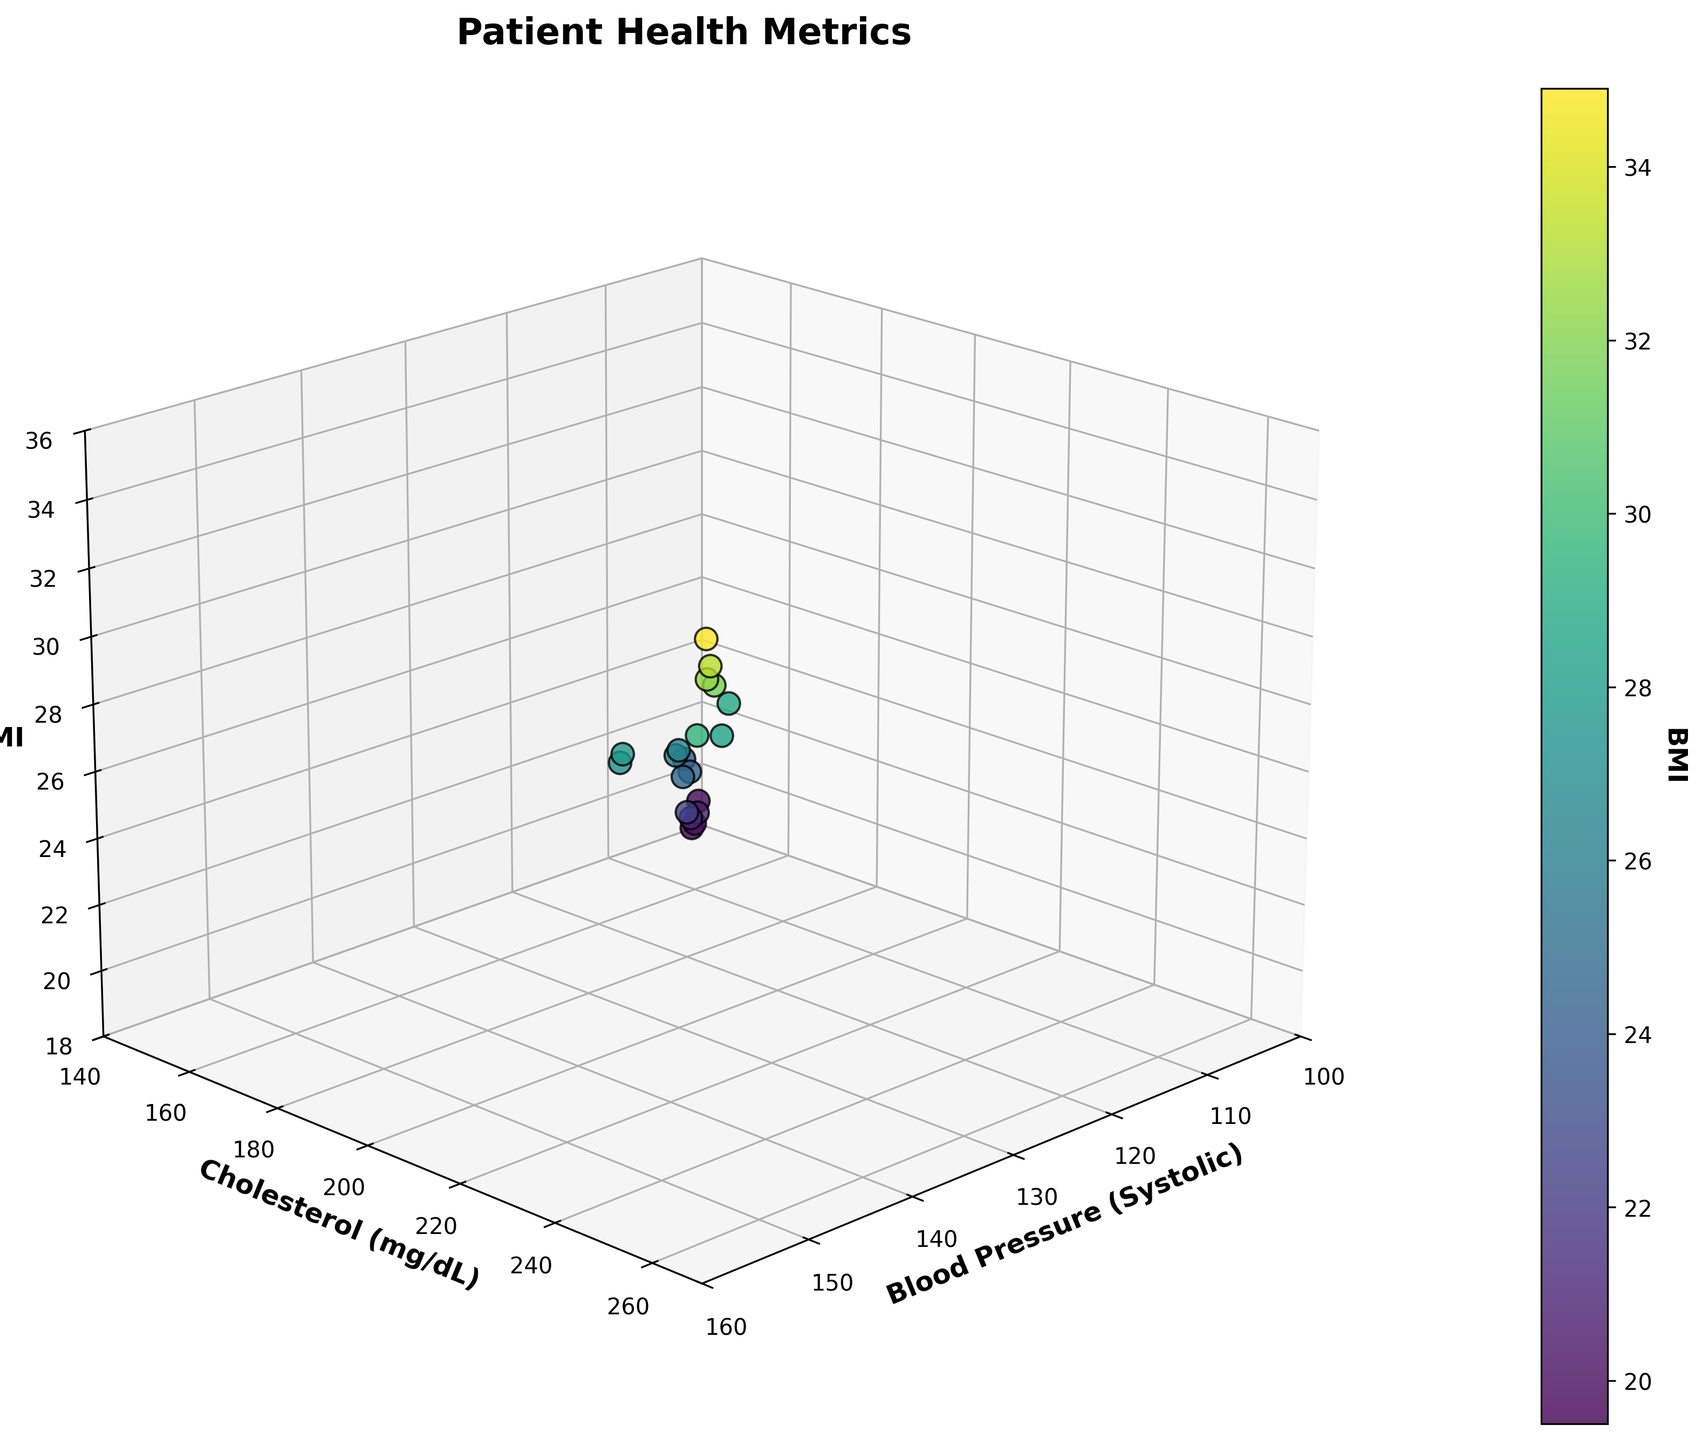What is the title of the 3D scatter plot? The title of the plot is usually displayed at the top center. From the description, it is "Patient Health Metrics".
Answer: Patient Health Metrics How many axes does the plot have? The plot is a 3D scatter plot, which means it has three axes: X, Y, and Z.
Answer: Three Which color gradient is used to represent the BMI values in the plot? The plot uses the 'viridis' color map, a gradient color map that transitions from blue to green to yellow representing low to high values of BMI.
Answer: Viridis What is the maximum value on the Blood Pressure (Systolic) axis? The X-axis label "Blood Pressure (Systolic)" will have the maximum bound set to 160 based on the predefined limit in the plot.
Answer: 160 Which axis represents Cholesterol levels? The axis labeled "Cholesterol (mg/dL)" represents the Cholesterol levels. This is the Y-axis in the plot.
Answer: Y-axis What's the lowest value of BMI plotted in this figure? The z-axis ticks show values ranging from 18 to 36. Observing the scatter points, the lowest BMI value visible is 19.5.
Answer: 19.5 How does the Blood Pressure correlate with BMI? Observing the scatter points' distribution and their colors (representing BMI), points seem to trend upward in BMI as blood pressure increases, indicating a positive correlation.
Answer: Positive correlation Compare the BMI values of patients with the highest and lowest Cholesterol levels. Identify the points with highest and lowest Y-values (Cholesterol): highest (260) BMI=34.9 and lowest (150) BMI=19.8.
Answer: 34.9 and 19.8 Do any patients have a Blood Pressure of 110 and a Cholesterol level above 250 mg/dL? Checking the scatter points, none appear at the intersection of Blood Pressure=110 and any Cholesterol value above 250.
Answer: No How many patients have a BMI greater than 30? Observing the color gradient and scatter point data, count how many BMI values exceed 30. Here, four patients meet this criterion.
Answer: Four 